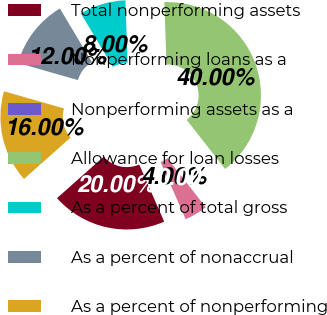<chart> <loc_0><loc_0><loc_500><loc_500><pie_chart><fcel>Total nonperforming assets<fcel>Nonperforming loans as a<fcel>Nonperforming assets as a<fcel>Allowance for loan losses<fcel>As a percent of total gross<fcel>As a percent of nonaccrual<fcel>As a percent of nonperforming<nl><fcel>20.0%<fcel>4.0%<fcel>0.0%<fcel>40.0%<fcel>8.0%<fcel>12.0%<fcel>16.0%<nl></chart> 